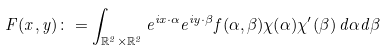<formula> <loc_0><loc_0><loc_500><loc_500>F ( x , y ) \colon = \int _ { \mathbb { R } ^ { 2 } \times \mathbb { R } ^ { 2 } } e ^ { i x \cdot \alpha } e ^ { i y \cdot \beta } f ( \alpha , \beta ) \chi ( \alpha ) \chi ^ { \prime } ( \beta ) \, d \alpha d \beta</formula> 